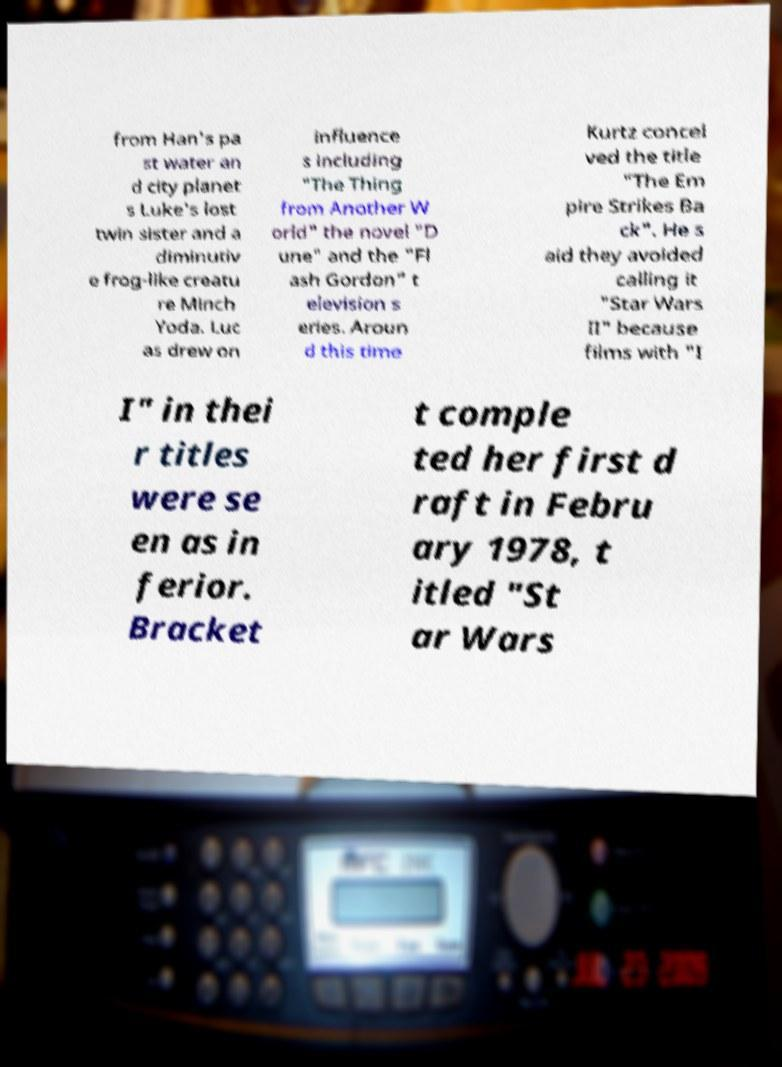I need the written content from this picture converted into text. Can you do that? from Han's pa st water an d city planet s Luke's lost twin sister and a diminutiv e frog-like creatu re Minch Yoda. Luc as drew on influence s including "The Thing from Another W orld" the novel "D une" and the "Fl ash Gordon" t elevision s eries. Aroun d this time Kurtz concei ved the title "The Em pire Strikes Ba ck". He s aid they avoided calling it "Star Wars II" because films with "I I" in thei r titles were se en as in ferior. Bracket t comple ted her first d raft in Febru ary 1978, t itled "St ar Wars 